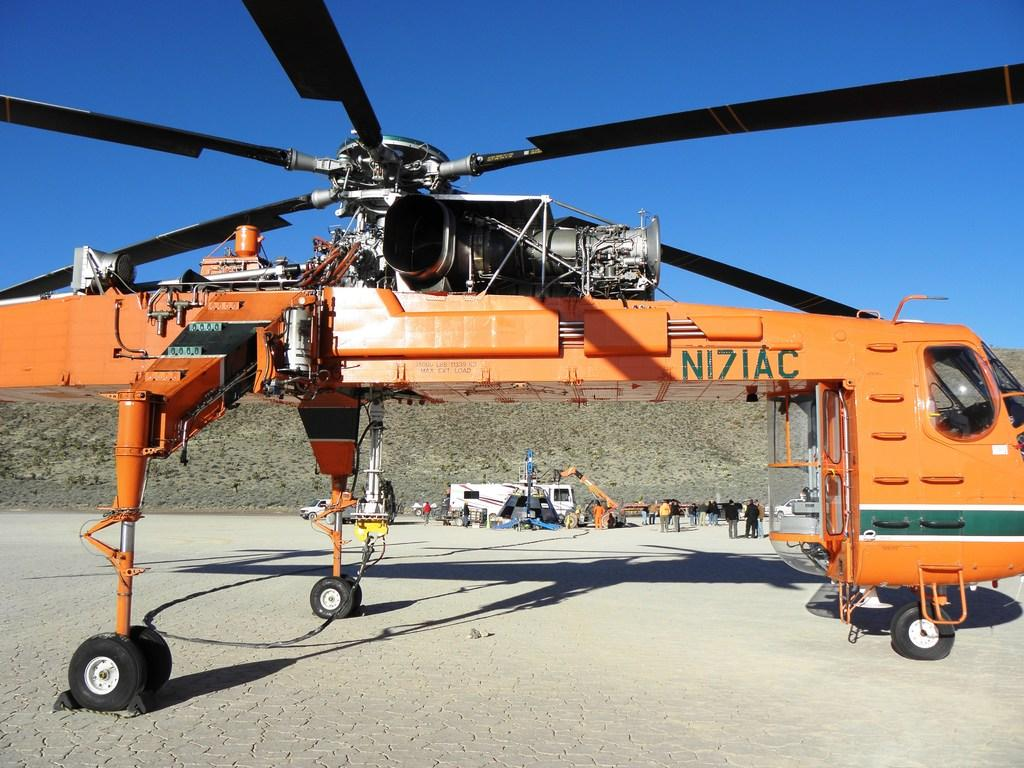What is the main subject in the foreground of the image? There is a chopper in the foreground of the image. Can you describe the people in the image? There are people in the image, but their specific actions or positions are not mentioned in the facts. What other objects or vehicles are present in the image? There are vehicles in the image, but their specific types or numbers are not mentioned in the facts. What can be seen in the background of the image? There is a mountain and the sky visible in the background of the image. What type of grip does the monkey have on the chopper in the image? There is no monkey present in the image, so it is not possible to answer that question. 